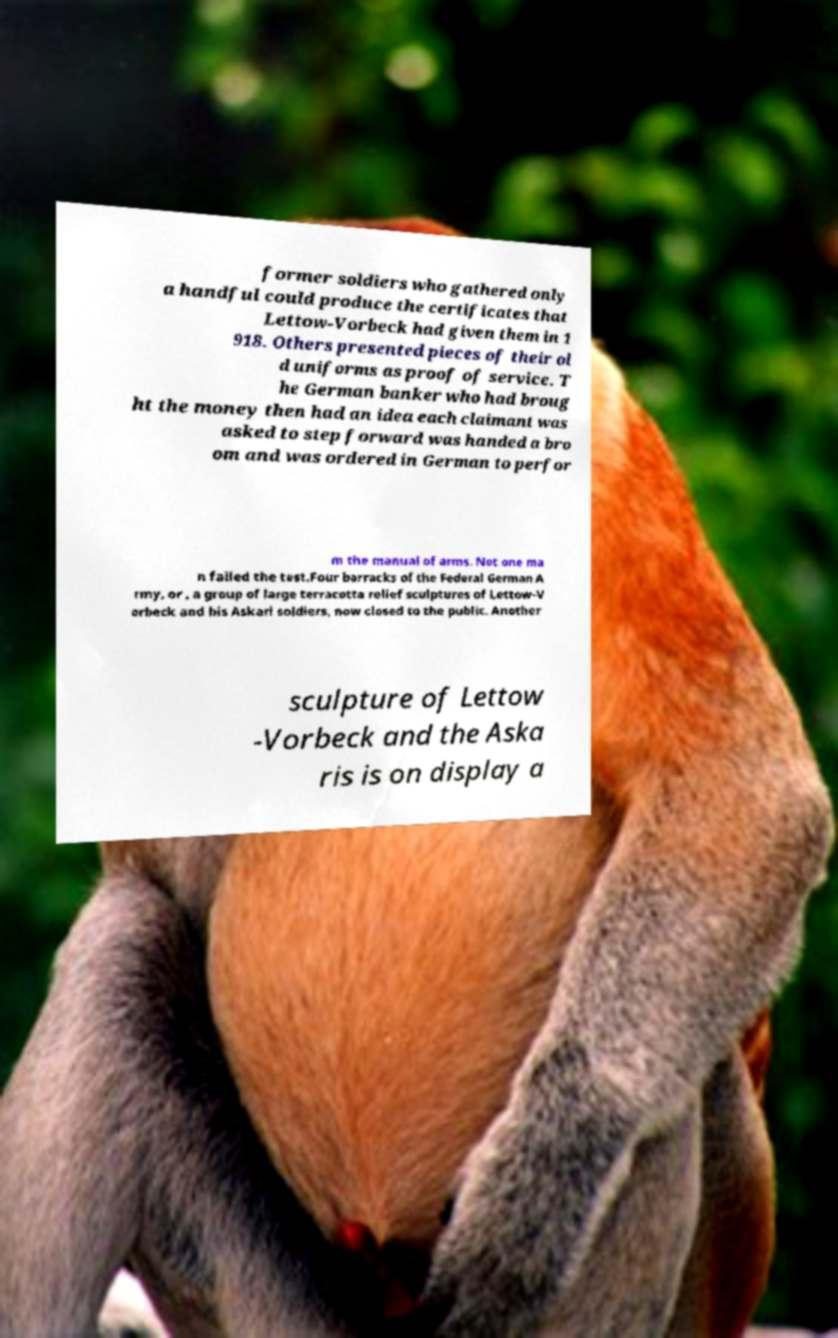For documentation purposes, I need the text within this image transcribed. Could you provide that? former soldiers who gathered only a handful could produce the certificates that Lettow-Vorbeck had given them in 1 918. Others presented pieces of their ol d uniforms as proof of service. T he German banker who had broug ht the money then had an idea each claimant was asked to step forward was handed a bro om and was ordered in German to perfor m the manual of arms. Not one ma n failed the test.Four barracks of the Federal German A rmy, or , a group of large terracotta relief sculptures of Lettow-V orbeck and his Askari soldiers, now closed to the public. Another sculpture of Lettow -Vorbeck and the Aska ris is on display a 